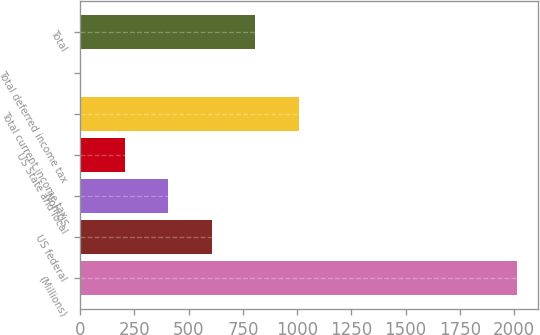<chart> <loc_0><loc_0><loc_500><loc_500><bar_chart><fcel>(Millions)<fcel>US federal<fcel>Non-US<fcel>US State and local<fcel>Total current income tax<fcel>Total deferred income tax<fcel>Total<nl><fcel>2011<fcel>606.1<fcel>405.4<fcel>204.7<fcel>1007.5<fcel>4<fcel>806.8<nl></chart> 